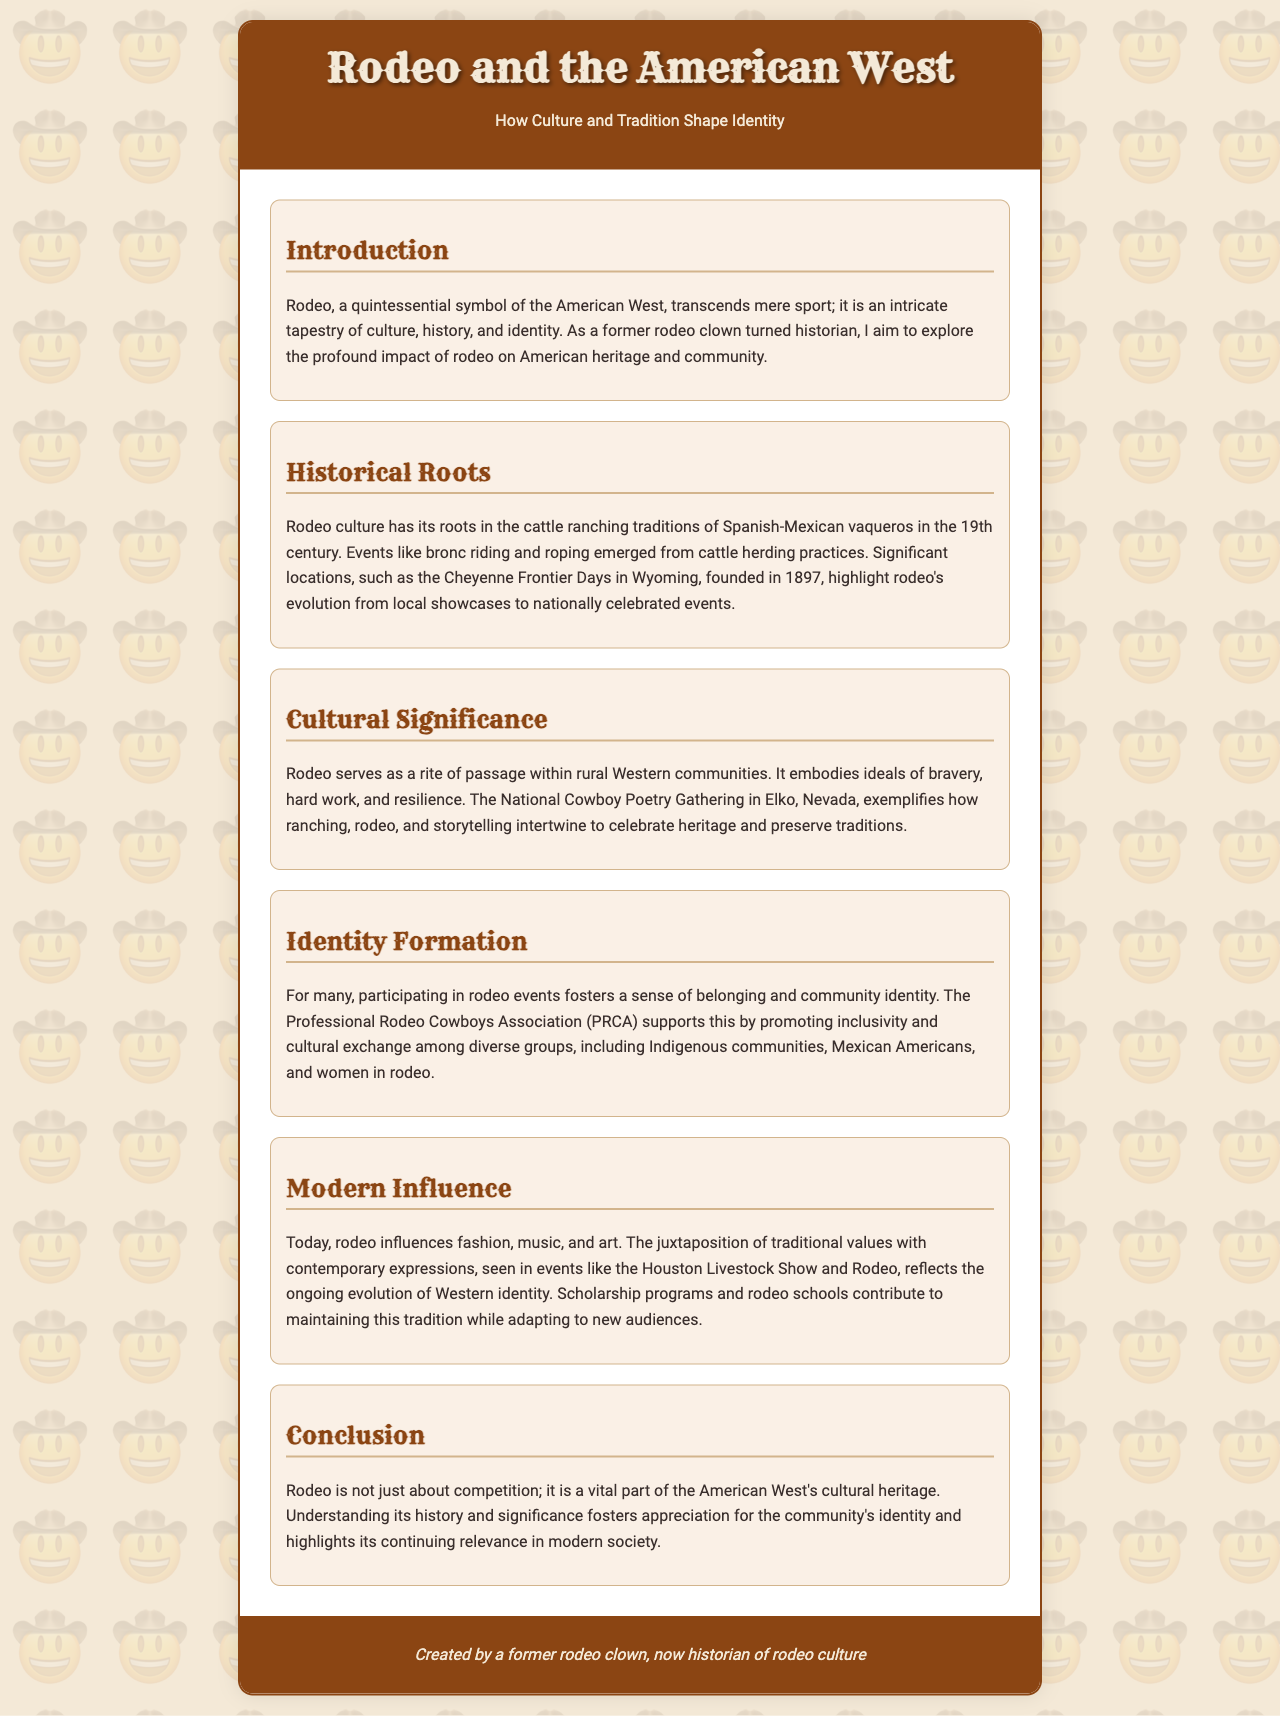what is the title of the brochure? The title of the brochure is prominently displayed in the header section.
Answer: Rodeo and the American West who are considered the historical roots of rodeo culture? The document discusses the origins of rodeo culture in relation to specific groups in history.
Answer: Spanish-Mexican vaqueros when was the Cheyenne Frontier Days founded? The founding year of the Cheyenne Frontier Days is mentioned in the Historical Roots section.
Answer: 1897 what is an example of an event that reflects rodeo's cultural significance? The Cultural Significance section provides a specific event that embodies rodeo's role in celebrating heritage.
Answer: National Cowboy Poetry Gathering which organization promotes inclusivity in rodeo? The Identity Formation section identifies a specific organization involved in promoting inclusivity.
Answer: Professional Rodeo Cowboys Association how does contemporary rodeo influence modern culture? The Modern Influence section outlines various aspects of contemporary life influenced by rodeo traditions.
Answer: Fashion, music, and art what is a key theme of rodeo events for participants? The document reveals an essential aspect of participation in rodeo events related to community.
Answer: Sense of belonging who created this brochure? The footer of the brochure attributes authorship to a specific individual.
Answer: A former rodeo clown, now historian of rodeo culture 